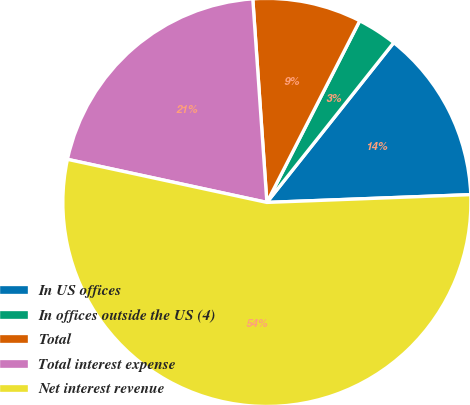Convert chart to OTSL. <chart><loc_0><loc_0><loc_500><loc_500><pie_chart><fcel>In US offices<fcel>In offices outside the US (4)<fcel>Total<fcel>Total interest expense<fcel>Net interest revenue<nl><fcel>13.71%<fcel>3.16%<fcel>8.62%<fcel>20.51%<fcel>53.99%<nl></chart> 